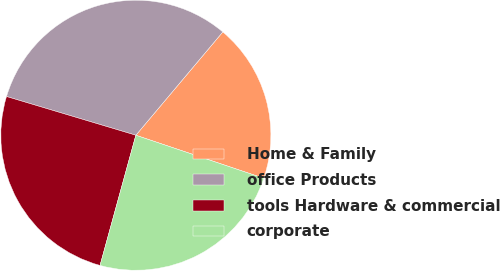Convert chart to OTSL. <chart><loc_0><loc_0><loc_500><loc_500><pie_chart><fcel>Home & Family<fcel>office Products<fcel>tools Hardware & commercial<fcel>corporate<nl><fcel>19.03%<fcel>31.51%<fcel>25.36%<fcel>24.11%<nl></chart> 